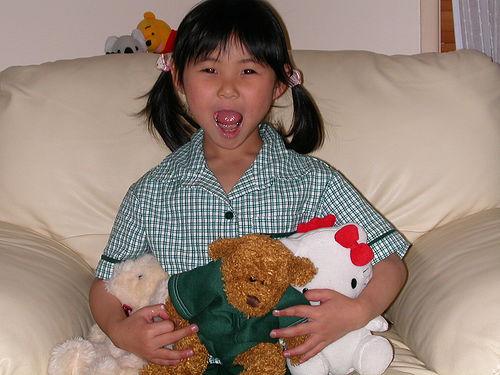What are the stuff animals resting on?
Answer briefly. Lap. Is the girl sitting?
Keep it brief. Yes. How many stuffed animals are in the picture?
Short answer required. 5. Is the girl happy?
Be succinct. Yes. 